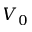<formula> <loc_0><loc_0><loc_500><loc_500>V _ { 0 }</formula> 